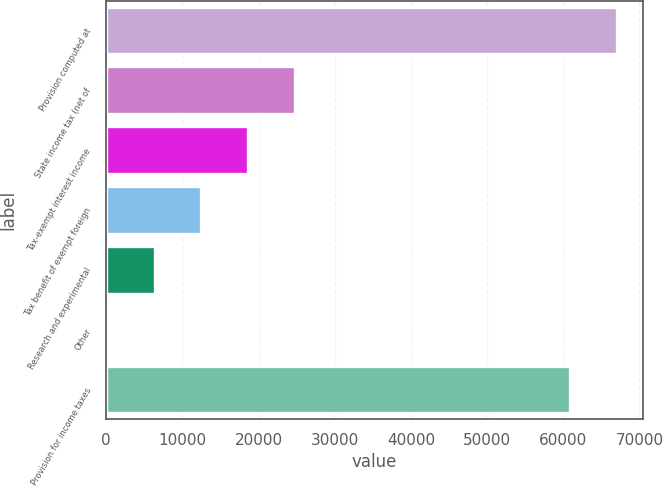<chart> <loc_0><loc_0><loc_500><loc_500><bar_chart><fcel>Provision computed at<fcel>State income tax (net of<fcel>Tax-exempt interest income<fcel>Tax benefit of exempt foreign<fcel>Research and experimental<fcel>Other<fcel>Provision for income taxes<nl><fcel>67086.9<fcel>24765.6<fcel>18621.7<fcel>12477.8<fcel>6333.9<fcel>190<fcel>60943<nl></chart> 